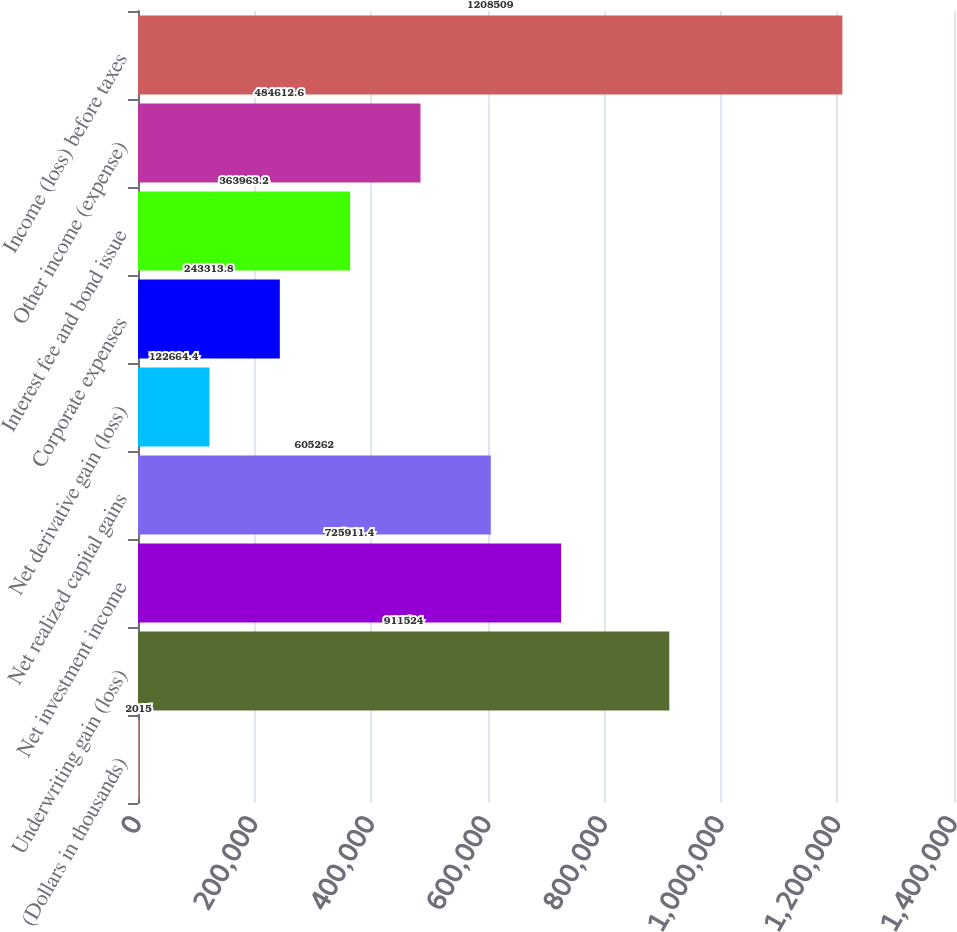Convert chart. <chart><loc_0><loc_0><loc_500><loc_500><bar_chart><fcel>(Dollars in thousands)<fcel>Underwriting gain (loss)<fcel>Net investment income<fcel>Net realized capital gains<fcel>Net derivative gain (loss)<fcel>Corporate expenses<fcel>Interest fee and bond issue<fcel>Other income (expense)<fcel>Income (loss) before taxes<nl><fcel>2015<fcel>911524<fcel>725911<fcel>605262<fcel>122664<fcel>243314<fcel>363963<fcel>484613<fcel>1.20851e+06<nl></chart> 